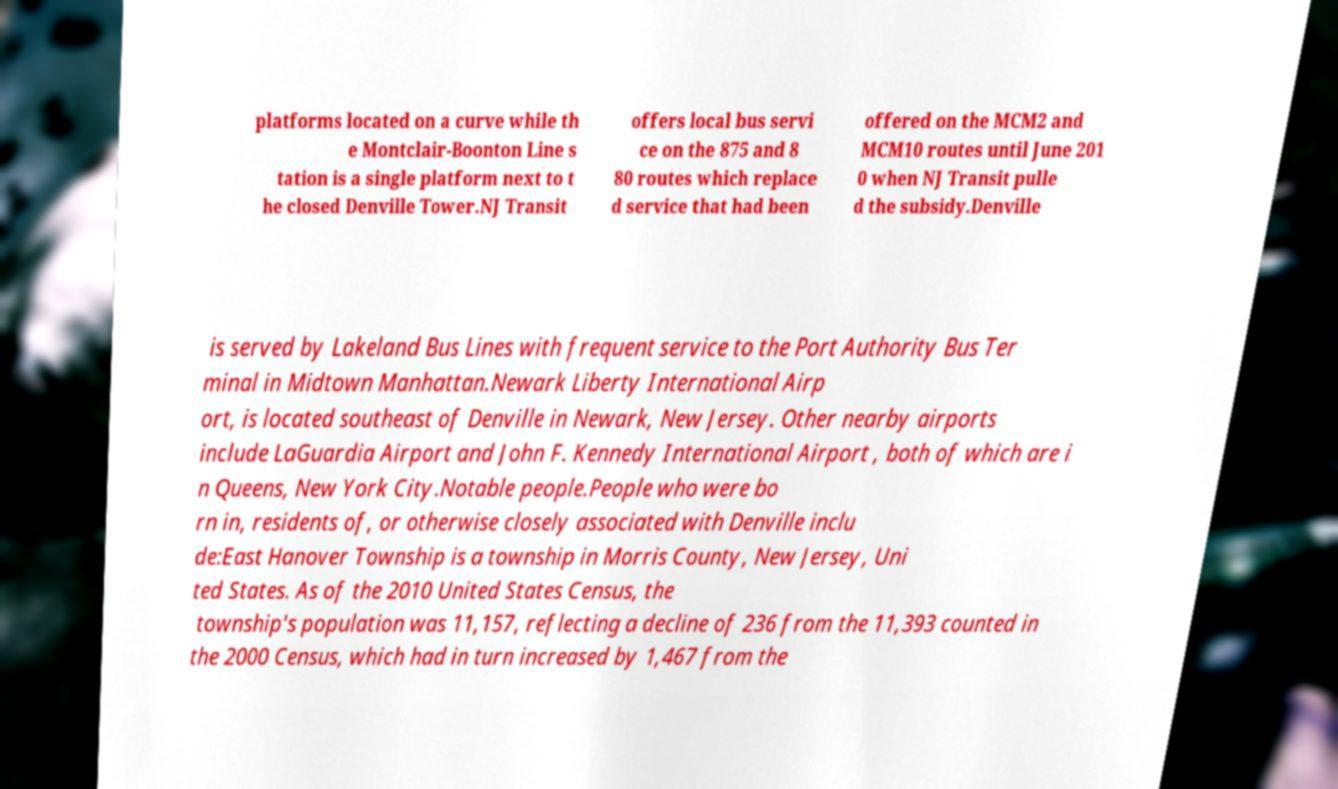Could you extract and type out the text from this image? platforms located on a curve while th e Montclair-Boonton Line s tation is a single platform next to t he closed Denville Tower.NJ Transit offers local bus servi ce on the 875 and 8 80 routes which replace d service that had been offered on the MCM2 and MCM10 routes until June 201 0 when NJ Transit pulle d the subsidy.Denville is served by Lakeland Bus Lines with frequent service to the Port Authority Bus Ter minal in Midtown Manhattan.Newark Liberty International Airp ort, is located southeast of Denville in Newark, New Jersey. Other nearby airports include LaGuardia Airport and John F. Kennedy International Airport , both of which are i n Queens, New York City.Notable people.People who were bo rn in, residents of, or otherwise closely associated with Denville inclu de:East Hanover Township is a township in Morris County, New Jersey, Uni ted States. As of the 2010 United States Census, the township's population was 11,157, reflecting a decline of 236 from the 11,393 counted in the 2000 Census, which had in turn increased by 1,467 from the 